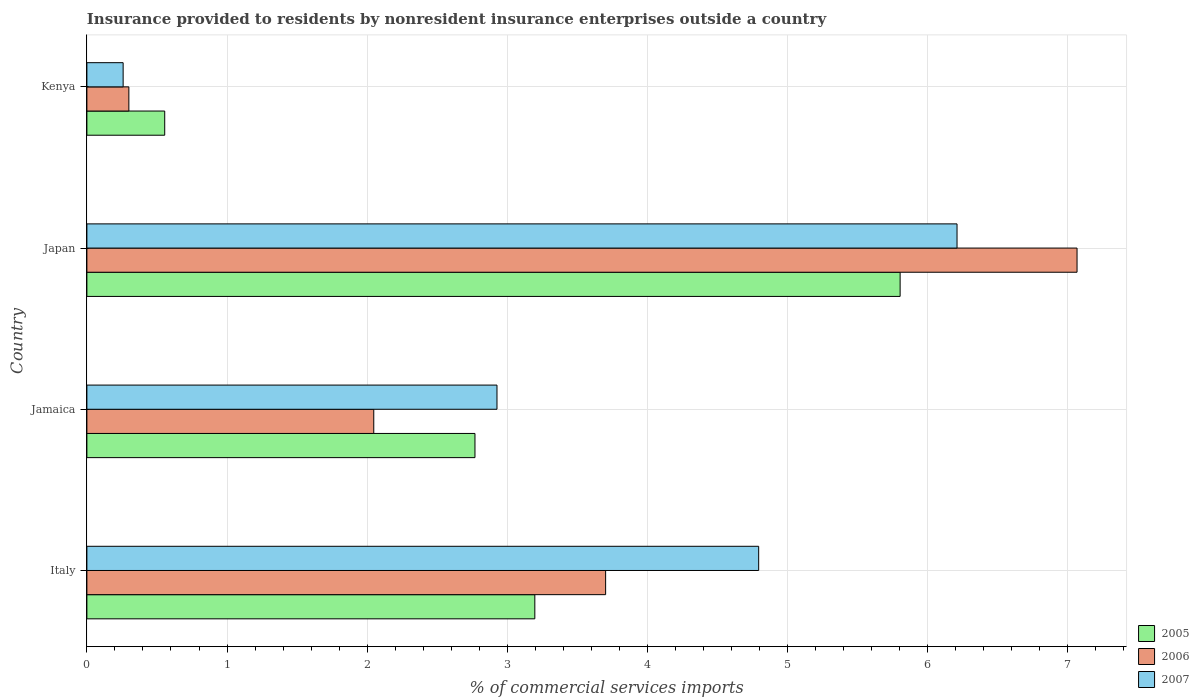How many different coloured bars are there?
Provide a short and direct response. 3. How many groups of bars are there?
Keep it short and to the point. 4. Are the number of bars per tick equal to the number of legend labels?
Your response must be concise. Yes. Are the number of bars on each tick of the Y-axis equal?
Offer a very short reply. Yes. How many bars are there on the 1st tick from the bottom?
Provide a short and direct response. 3. What is the Insurance provided to residents in 2005 in Italy?
Give a very brief answer. 3.2. Across all countries, what is the maximum Insurance provided to residents in 2006?
Ensure brevity in your answer.  7.07. Across all countries, what is the minimum Insurance provided to residents in 2006?
Provide a short and direct response. 0.3. In which country was the Insurance provided to residents in 2005 maximum?
Offer a terse response. Japan. In which country was the Insurance provided to residents in 2007 minimum?
Provide a short and direct response. Kenya. What is the total Insurance provided to residents in 2006 in the graph?
Give a very brief answer. 13.12. What is the difference between the Insurance provided to residents in 2006 in Japan and that in Kenya?
Ensure brevity in your answer.  6.77. What is the difference between the Insurance provided to residents in 2007 in Italy and the Insurance provided to residents in 2006 in Kenya?
Offer a terse response. 4.49. What is the average Insurance provided to residents in 2005 per country?
Your response must be concise. 3.08. What is the difference between the Insurance provided to residents in 2007 and Insurance provided to residents in 2005 in Japan?
Your answer should be very brief. 0.41. What is the ratio of the Insurance provided to residents in 2007 in Jamaica to that in Kenya?
Provide a succinct answer. 11.32. What is the difference between the highest and the second highest Insurance provided to residents in 2007?
Your response must be concise. 1.42. What is the difference between the highest and the lowest Insurance provided to residents in 2005?
Provide a short and direct response. 5.25. In how many countries, is the Insurance provided to residents in 2005 greater than the average Insurance provided to residents in 2005 taken over all countries?
Provide a short and direct response. 2. What does the 3rd bar from the top in Italy represents?
Your answer should be very brief. 2005. What does the 1st bar from the bottom in Jamaica represents?
Offer a terse response. 2005. Are all the bars in the graph horizontal?
Make the answer very short. Yes. How many countries are there in the graph?
Your answer should be compact. 4. What is the difference between two consecutive major ticks on the X-axis?
Keep it short and to the point. 1. Are the values on the major ticks of X-axis written in scientific E-notation?
Provide a short and direct response. No. Where does the legend appear in the graph?
Your answer should be very brief. Bottom right. How many legend labels are there?
Your answer should be compact. 3. What is the title of the graph?
Offer a terse response. Insurance provided to residents by nonresident insurance enterprises outside a country. What is the label or title of the X-axis?
Your response must be concise. % of commercial services imports. What is the label or title of the Y-axis?
Ensure brevity in your answer.  Country. What is the % of commercial services imports of 2005 in Italy?
Keep it short and to the point. 3.2. What is the % of commercial services imports of 2006 in Italy?
Your response must be concise. 3.7. What is the % of commercial services imports of 2007 in Italy?
Offer a very short reply. 4.79. What is the % of commercial services imports of 2005 in Jamaica?
Make the answer very short. 2.77. What is the % of commercial services imports of 2006 in Jamaica?
Your response must be concise. 2.05. What is the % of commercial services imports of 2007 in Jamaica?
Provide a short and direct response. 2.93. What is the % of commercial services imports of 2005 in Japan?
Your response must be concise. 5.8. What is the % of commercial services imports of 2006 in Japan?
Offer a very short reply. 7.07. What is the % of commercial services imports in 2007 in Japan?
Make the answer very short. 6.21. What is the % of commercial services imports of 2005 in Kenya?
Your answer should be very brief. 0.56. What is the % of commercial services imports of 2006 in Kenya?
Your answer should be compact. 0.3. What is the % of commercial services imports in 2007 in Kenya?
Give a very brief answer. 0.26. Across all countries, what is the maximum % of commercial services imports of 2005?
Make the answer very short. 5.8. Across all countries, what is the maximum % of commercial services imports of 2006?
Give a very brief answer. 7.07. Across all countries, what is the maximum % of commercial services imports of 2007?
Ensure brevity in your answer.  6.21. Across all countries, what is the minimum % of commercial services imports in 2005?
Offer a very short reply. 0.56. Across all countries, what is the minimum % of commercial services imports in 2006?
Ensure brevity in your answer.  0.3. Across all countries, what is the minimum % of commercial services imports in 2007?
Offer a terse response. 0.26. What is the total % of commercial services imports in 2005 in the graph?
Provide a succinct answer. 12.33. What is the total % of commercial services imports of 2006 in the graph?
Give a very brief answer. 13.12. What is the total % of commercial services imports in 2007 in the graph?
Make the answer very short. 14.19. What is the difference between the % of commercial services imports of 2005 in Italy and that in Jamaica?
Keep it short and to the point. 0.43. What is the difference between the % of commercial services imports in 2006 in Italy and that in Jamaica?
Keep it short and to the point. 1.65. What is the difference between the % of commercial services imports of 2007 in Italy and that in Jamaica?
Offer a very short reply. 1.87. What is the difference between the % of commercial services imports in 2005 in Italy and that in Japan?
Your response must be concise. -2.61. What is the difference between the % of commercial services imports in 2006 in Italy and that in Japan?
Give a very brief answer. -3.36. What is the difference between the % of commercial services imports in 2007 in Italy and that in Japan?
Your answer should be very brief. -1.42. What is the difference between the % of commercial services imports in 2005 in Italy and that in Kenya?
Provide a short and direct response. 2.64. What is the difference between the % of commercial services imports of 2006 in Italy and that in Kenya?
Make the answer very short. 3.4. What is the difference between the % of commercial services imports in 2007 in Italy and that in Kenya?
Provide a succinct answer. 4.54. What is the difference between the % of commercial services imports of 2005 in Jamaica and that in Japan?
Provide a succinct answer. -3.03. What is the difference between the % of commercial services imports of 2006 in Jamaica and that in Japan?
Your response must be concise. -5.02. What is the difference between the % of commercial services imports in 2007 in Jamaica and that in Japan?
Make the answer very short. -3.28. What is the difference between the % of commercial services imports in 2005 in Jamaica and that in Kenya?
Offer a very short reply. 2.21. What is the difference between the % of commercial services imports of 2006 in Jamaica and that in Kenya?
Offer a terse response. 1.75. What is the difference between the % of commercial services imports in 2007 in Jamaica and that in Kenya?
Ensure brevity in your answer.  2.67. What is the difference between the % of commercial services imports in 2005 in Japan and that in Kenya?
Offer a very short reply. 5.25. What is the difference between the % of commercial services imports in 2006 in Japan and that in Kenya?
Your response must be concise. 6.77. What is the difference between the % of commercial services imports in 2007 in Japan and that in Kenya?
Your answer should be very brief. 5.95. What is the difference between the % of commercial services imports of 2005 in Italy and the % of commercial services imports of 2006 in Jamaica?
Offer a terse response. 1.15. What is the difference between the % of commercial services imports in 2005 in Italy and the % of commercial services imports in 2007 in Jamaica?
Offer a very short reply. 0.27. What is the difference between the % of commercial services imports of 2006 in Italy and the % of commercial services imports of 2007 in Jamaica?
Make the answer very short. 0.78. What is the difference between the % of commercial services imports in 2005 in Italy and the % of commercial services imports in 2006 in Japan?
Provide a succinct answer. -3.87. What is the difference between the % of commercial services imports of 2005 in Italy and the % of commercial services imports of 2007 in Japan?
Provide a succinct answer. -3.01. What is the difference between the % of commercial services imports of 2006 in Italy and the % of commercial services imports of 2007 in Japan?
Make the answer very short. -2.51. What is the difference between the % of commercial services imports in 2005 in Italy and the % of commercial services imports in 2006 in Kenya?
Your answer should be very brief. 2.9. What is the difference between the % of commercial services imports of 2005 in Italy and the % of commercial services imports of 2007 in Kenya?
Your answer should be very brief. 2.94. What is the difference between the % of commercial services imports in 2006 in Italy and the % of commercial services imports in 2007 in Kenya?
Ensure brevity in your answer.  3.44. What is the difference between the % of commercial services imports in 2005 in Jamaica and the % of commercial services imports in 2006 in Japan?
Offer a terse response. -4.3. What is the difference between the % of commercial services imports of 2005 in Jamaica and the % of commercial services imports of 2007 in Japan?
Provide a short and direct response. -3.44. What is the difference between the % of commercial services imports of 2006 in Jamaica and the % of commercial services imports of 2007 in Japan?
Give a very brief answer. -4.16. What is the difference between the % of commercial services imports of 2005 in Jamaica and the % of commercial services imports of 2006 in Kenya?
Offer a terse response. 2.47. What is the difference between the % of commercial services imports in 2005 in Jamaica and the % of commercial services imports in 2007 in Kenya?
Provide a succinct answer. 2.51. What is the difference between the % of commercial services imports in 2006 in Jamaica and the % of commercial services imports in 2007 in Kenya?
Keep it short and to the point. 1.79. What is the difference between the % of commercial services imports of 2005 in Japan and the % of commercial services imports of 2006 in Kenya?
Provide a succinct answer. 5.5. What is the difference between the % of commercial services imports in 2005 in Japan and the % of commercial services imports in 2007 in Kenya?
Your answer should be compact. 5.54. What is the difference between the % of commercial services imports in 2006 in Japan and the % of commercial services imports in 2007 in Kenya?
Ensure brevity in your answer.  6.81. What is the average % of commercial services imports in 2005 per country?
Your answer should be compact. 3.08. What is the average % of commercial services imports in 2006 per country?
Your answer should be compact. 3.28. What is the average % of commercial services imports in 2007 per country?
Your answer should be very brief. 3.55. What is the difference between the % of commercial services imports in 2005 and % of commercial services imports in 2006 in Italy?
Your answer should be very brief. -0.51. What is the difference between the % of commercial services imports in 2005 and % of commercial services imports in 2007 in Italy?
Make the answer very short. -1.6. What is the difference between the % of commercial services imports in 2006 and % of commercial services imports in 2007 in Italy?
Offer a very short reply. -1.09. What is the difference between the % of commercial services imports of 2005 and % of commercial services imports of 2006 in Jamaica?
Your answer should be compact. 0.72. What is the difference between the % of commercial services imports of 2005 and % of commercial services imports of 2007 in Jamaica?
Provide a succinct answer. -0.16. What is the difference between the % of commercial services imports in 2006 and % of commercial services imports in 2007 in Jamaica?
Make the answer very short. -0.88. What is the difference between the % of commercial services imports of 2005 and % of commercial services imports of 2006 in Japan?
Provide a succinct answer. -1.26. What is the difference between the % of commercial services imports in 2005 and % of commercial services imports in 2007 in Japan?
Offer a terse response. -0.41. What is the difference between the % of commercial services imports in 2006 and % of commercial services imports in 2007 in Japan?
Make the answer very short. 0.86. What is the difference between the % of commercial services imports in 2005 and % of commercial services imports in 2006 in Kenya?
Your answer should be very brief. 0.26. What is the difference between the % of commercial services imports of 2005 and % of commercial services imports of 2007 in Kenya?
Keep it short and to the point. 0.3. What is the difference between the % of commercial services imports in 2006 and % of commercial services imports in 2007 in Kenya?
Offer a very short reply. 0.04. What is the ratio of the % of commercial services imports in 2005 in Italy to that in Jamaica?
Keep it short and to the point. 1.15. What is the ratio of the % of commercial services imports in 2006 in Italy to that in Jamaica?
Your answer should be compact. 1.81. What is the ratio of the % of commercial services imports in 2007 in Italy to that in Jamaica?
Ensure brevity in your answer.  1.64. What is the ratio of the % of commercial services imports of 2005 in Italy to that in Japan?
Give a very brief answer. 0.55. What is the ratio of the % of commercial services imports of 2006 in Italy to that in Japan?
Give a very brief answer. 0.52. What is the ratio of the % of commercial services imports of 2007 in Italy to that in Japan?
Offer a terse response. 0.77. What is the ratio of the % of commercial services imports in 2005 in Italy to that in Kenya?
Give a very brief answer. 5.76. What is the ratio of the % of commercial services imports in 2006 in Italy to that in Kenya?
Your answer should be compact. 12.36. What is the ratio of the % of commercial services imports of 2007 in Italy to that in Kenya?
Offer a terse response. 18.54. What is the ratio of the % of commercial services imports of 2005 in Jamaica to that in Japan?
Your answer should be very brief. 0.48. What is the ratio of the % of commercial services imports in 2006 in Jamaica to that in Japan?
Offer a very short reply. 0.29. What is the ratio of the % of commercial services imports of 2007 in Jamaica to that in Japan?
Keep it short and to the point. 0.47. What is the ratio of the % of commercial services imports in 2005 in Jamaica to that in Kenya?
Provide a succinct answer. 4.99. What is the ratio of the % of commercial services imports in 2006 in Jamaica to that in Kenya?
Your answer should be very brief. 6.84. What is the ratio of the % of commercial services imports of 2007 in Jamaica to that in Kenya?
Give a very brief answer. 11.32. What is the ratio of the % of commercial services imports of 2005 in Japan to that in Kenya?
Keep it short and to the point. 10.45. What is the ratio of the % of commercial services imports in 2006 in Japan to that in Kenya?
Offer a terse response. 23.59. What is the ratio of the % of commercial services imports of 2007 in Japan to that in Kenya?
Provide a succinct answer. 24.01. What is the difference between the highest and the second highest % of commercial services imports in 2005?
Offer a very short reply. 2.61. What is the difference between the highest and the second highest % of commercial services imports of 2006?
Provide a succinct answer. 3.36. What is the difference between the highest and the second highest % of commercial services imports in 2007?
Provide a succinct answer. 1.42. What is the difference between the highest and the lowest % of commercial services imports of 2005?
Keep it short and to the point. 5.25. What is the difference between the highest and the lowest % of commercial services imports in 2006?
Provide a succinct answer. 6.77. What is the difference between the highest and the lowest % of commercial services imports in 2007?
Offer a terse response. 5.95. 